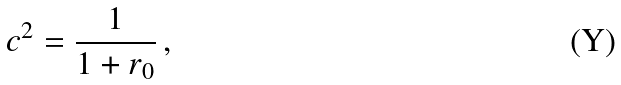<formula> <loc_0><loc_0><loc_500><loc_500>c ^ { 2 } = \frac { 1 } { 1 + r _ { 0 } } \, ,</formula> 